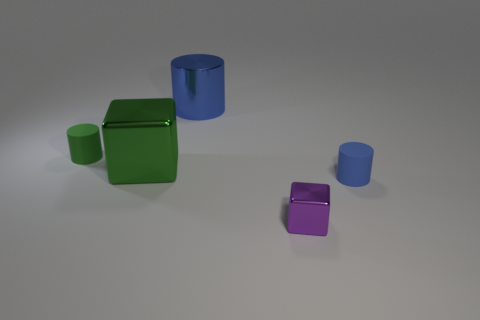What number of tiny cylinders are both right of the tiny purple metal block and on the left side of the metallic cylinder? 0 